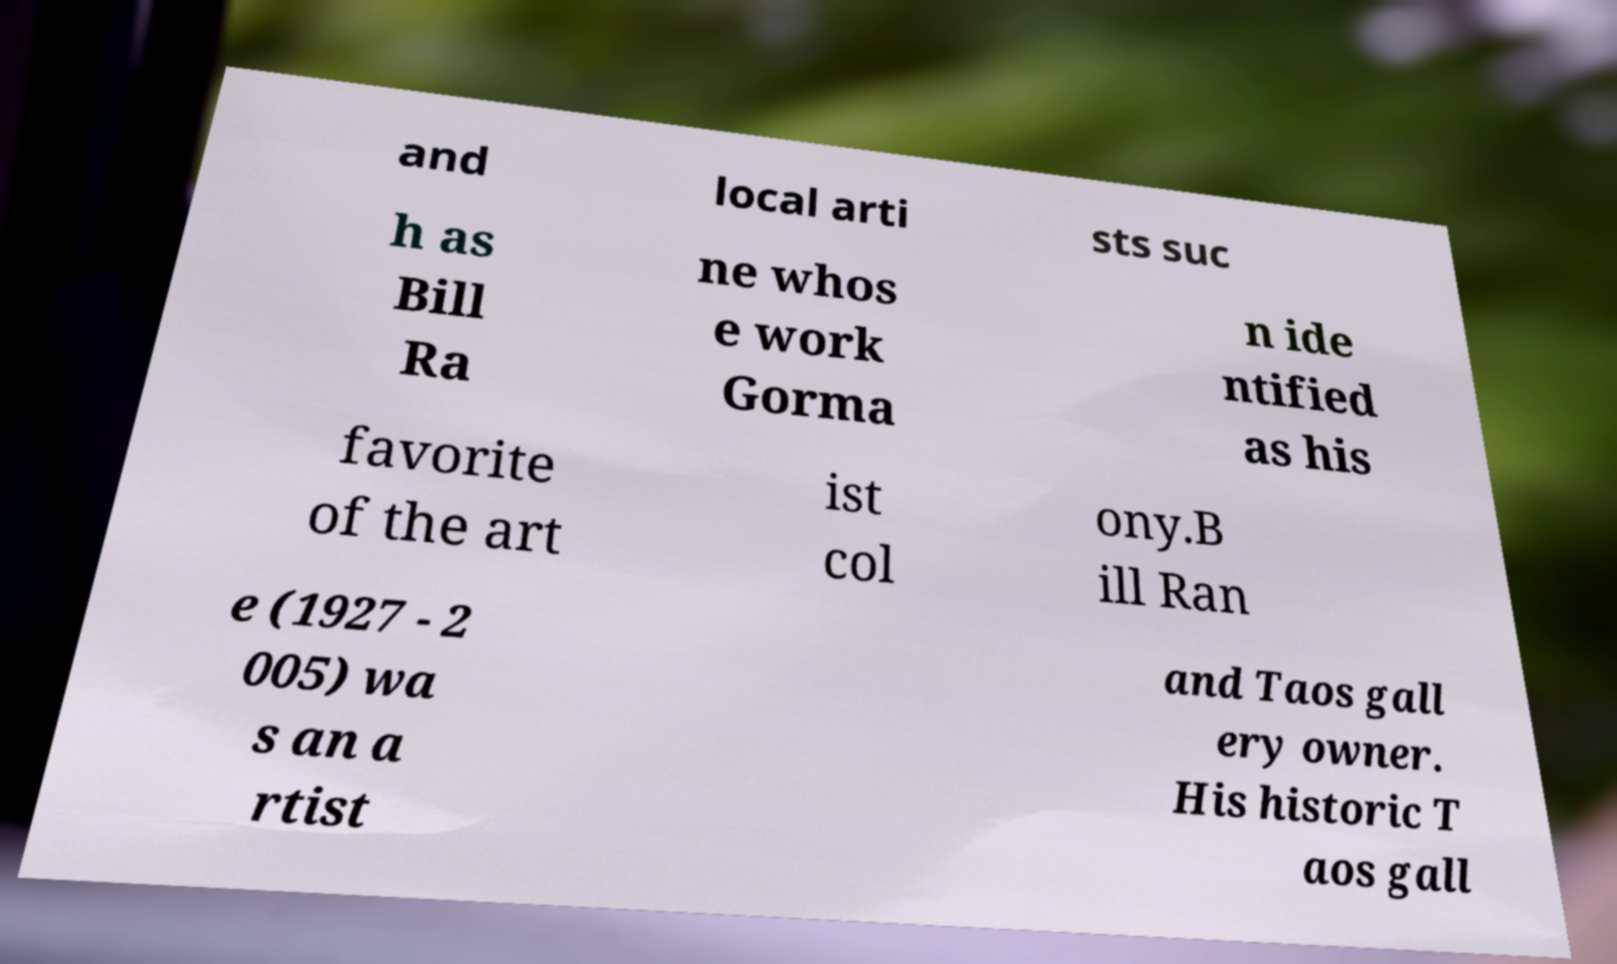Could you extract and type out the text from this image? and local arti sts suc h as Bill Ra ne whos e work Gorma n ide ntified as his favorite of the art ist col ony.B ill Ran e (1927 - 2 005) wa s an a rtist and Taos gall ery owner. His historic T aos gall 